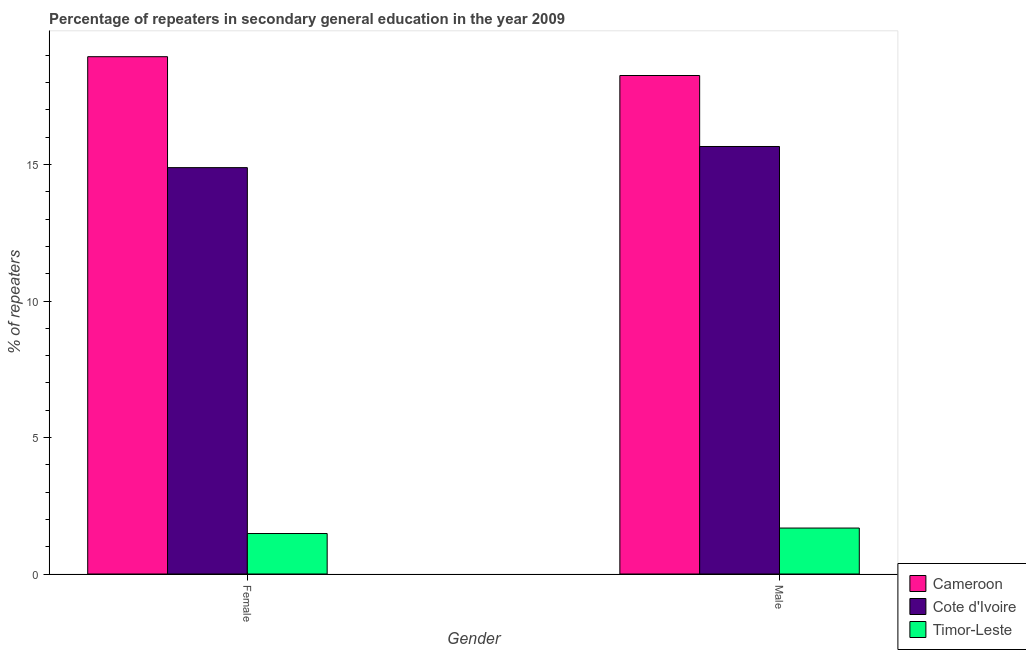How many groups of bars are there?
Offer a very short reply. 2. Are the number of bars per tick equal to the number of legend labels?
Your response must be concise. Yes. What is the percentage of male repeaters in Cameroon?
Keep it short and to the point. 18.26. Across all countries, what is the maximum percentage of male repeaters?
Your answer should be compact. 18.26. Across all countries, what is the minimum percentage of female repeaters?
Make the answer very short. 1.48. In which country was the percentage of male repeaters maximum?
Your answer should be compact. Cameroon. In which country was the percentage of male repeaters minimum?
Your answer should be very brief. Timor-Leste. What is the total percentage of female repeaters in the graph?
Make the answer very short. 35.32. What is the difference between the percentage of female repeaters in Timor-Leste and that in Cote d'Ivoire?
Make the answer very short. -13.4. What is the difference between the percentage of male repeaters in Cote d'Ivoire and the percentage of female repeaters in Timor-Leste?
Provide a short and direct response. 14.18. What is the average percentage of female repeaters per country?
Offer a terse response. 11.77. What is the difference between the percentage of female repeaters and percentage of male repeaters in Cote d'Ivoire?
Provide a succinct answer. -0.77. In how many countries, is the percentage of male repeaters greater than 10 %?
Give a very brief answer. 2. What is the ratio of the percentage of male repeaters in Cote d'Ivoire to that in Timor-Leste?
Offer a very short reply. 9.3. Is the percentage of male repeaters in Cameroon less than that in Cote d'Ivoire?
Your answer should be compact. No. What does the 2nd bar from the left in Female represents?
Keep it short and to the point. Cote d'Ivoire. What does the 3rd bar from the right in Female represents?
Ensure brevity in your answer.  Cameroon. Does the graph contain any zero values?
Your answer should be very brief. No. Does the graph contain grids?
Make the answer very short. No. How are the legend labels stacked?
Make the answer very short. Vertical. What is the title of the graph?
Keep it short and to the point. Percentage of repeaters in secondary general education in the year 2009. What is the label or title of the Y-axis?
Ensure brevity in your answer.  % of repeaters. What is the % of repeaters of Cameroon in Female?
Your answer should be compact. 18.95. What is the % of repeaters in Cote d'Ivoire in Female?
Your answer should be very brief. 14.89. What is the % of repeaters of Timor-Leste in Female?
Offer a very short reply. 1.48. What is the % of repeaters in Cameroon in Male?
Make the answer very short. 18.26. What is the % of repeaters of Cote d'Ivoire in Male?
Keep it short and to the point. 15.66. What is the % of repeaters in Timor-Leste in Male?
Your answer should be very brief. 1.68. Across all Gender, what is the maximum % of repeaters in Cameroon?
Keep it short and to the point. 18.95. Across all Gender, what is the maximum % of repeaters of Cote d'Ivoire?
Give a very brief answer. 15.66. Across all Gender, what is the maximum % of repeaters in Timor-Leste?
Your answer should be very brief. 1.68. Across all Gender, what is the minimum % of repeaters in Cameroon?
Ensure brevity in your answer.  18.26. Across all Gender, what is the minimum % of repeaters of Cote d'Ivoire?
Your answer should be compact. 14.89. Across all Gender, what is the minimum % of repeaters in Timor-Leste?
Your response must be concise. 1.48. What is the total % of repeaters in Cameroon in the graph?
Give a very brief answer. 37.21. What is the total % of repeaters in Cote d'Ivoire in the graph?
Offer a terse response. 30.55. What is the total % of repeaters in Timor-Leste in the graph?
Keep it short and to the point. 3.17. What is the difference between the % of repeaters of Cameroon in Female and that in Male?
Your answer should be very brief. 0.69. What is the difference between the % of repeaters of Cote d'Ivoire in Female and that in Male?
Make the answer very short. -0.77. What is the difference between the % of repeaters in Timor-Leste in Female and that in Male?
Ensure brevity in your answer.  -0.2. What is the difference between the % of repeaters in Cameroon in Female and the % of repeaters in Cote d'Ivoire in Male?
Your response must be concise. 3.29. What is the difference between the % of repeaters in Cameroon in Female and the % of repeaters in Timor-Leste in Male?
Offer a terse response. 17.27. What is the difference between the % of repeaters in Cote d'Ivoire in Female and the % of repeaters in Timor-Leste in Male?
Provide a succinct answer. 13.2. What is the average % of repeaters in Cameroon per Gender?
Provide a succinct answer. 18.61. What is the average % of repeaters of Cote d'Ivoire per Gender?
Offer a terse response. 15.27. What is the average % of repeaters in Timor-Leste per Gender?
Your response must be concise. 1.58. What is the difference between the % of repeaters of Cameroon and % of repeaters of Cote d'Ivoire in Female?
Offer a terse response. 4.06. What is the difference between the % of repeaters in Cameroon and % of repeaters in Timor-Leste in Female?
Your response must be concise. 17.47. What is the difference between the % of repeaters in Cote d'Ivoire and % of repeaters in Timor-Leste in Female?
Your response must be concise. 13.4. What is the difference between the % of repeaters in Cameroon and % of repeaters in Cote d'Ivoire in Male?
Keep it short and to the point. 2.6. What is the difference between the % of repeaters of Cameroon and % of repeaters of Timor-Leste in Male?
Offer a very short reply. 16.58. What is the difference between the % of repeaters in Cote d'Ivoire and % of repeaters in Timor-Leste in Male?
Make the answer very short. 13.98. What is the ratio of the % of repeaters in Cameroon in Female to that in Male?
Your answer should be compact. 1.04. What is the ratio of the % of repeaters of Cote d'Ivoire in Female to that in Male?
Ensure brevity in your answer.  0.95. What is the ratio of the % of repeaters of Timor-Leste in Female to that in Male?
Make the answer very short. 0.88. What is the difference between the highest and the second highest % of repeaters in Cameroon?
Offer a terse response. 0.69. What is the difference between the highest and the second highest % of repeaters in Cote d'Ivoire?
Keep it short and to the point. 0.77. What is the difference between the highest and the second highest % of repeaters in Timor-Leste?
Your answer should be compact. 0.2. What is the difference between the highest and the lowest % of repeaters in Cameroon?
Provide a short and direct response. 0.69. What is the difference between the highest and the lowest % of repeaters in Cote d'Ivoire?
Give a very brief answer. 0.77. What is the difference between the highest and the lowest % of repeaters in Timor-Leste?
Ensure brevity in your answer.  0.2. 